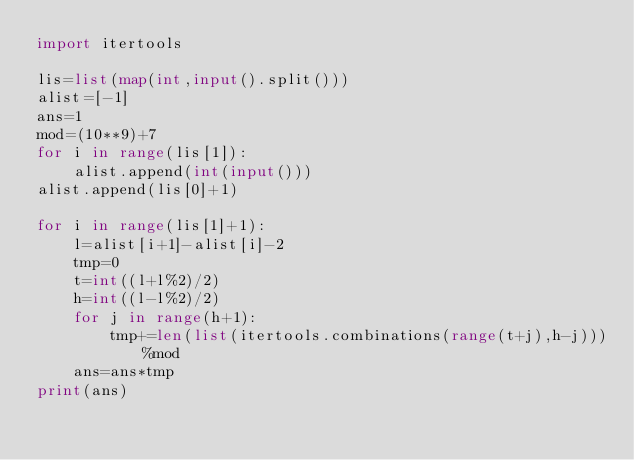Convert code to text. <code><loc_0><loc_0><loc_500><loc_500><_Python_>import itertools

lis=list(map(int,input().split()))
alist=[-1]
ans=1
mod=(10**9)+7
for i in range(lis[1]):
    alist.append(int(input()))
alist.append(lis[0]+1)

for i in range(lis[1]+1):
    l=alist[i+1]-alist[i]-2
    tmp=0
    t=int((l+l%2)/2)
    h=int((l-l%2)/2)
    for j in range(h+1):
        tmp+=len(list(itertools.combinations(range(t+j),h-j)))%mod
    ans=ans*tmp
print(ans)</code> 